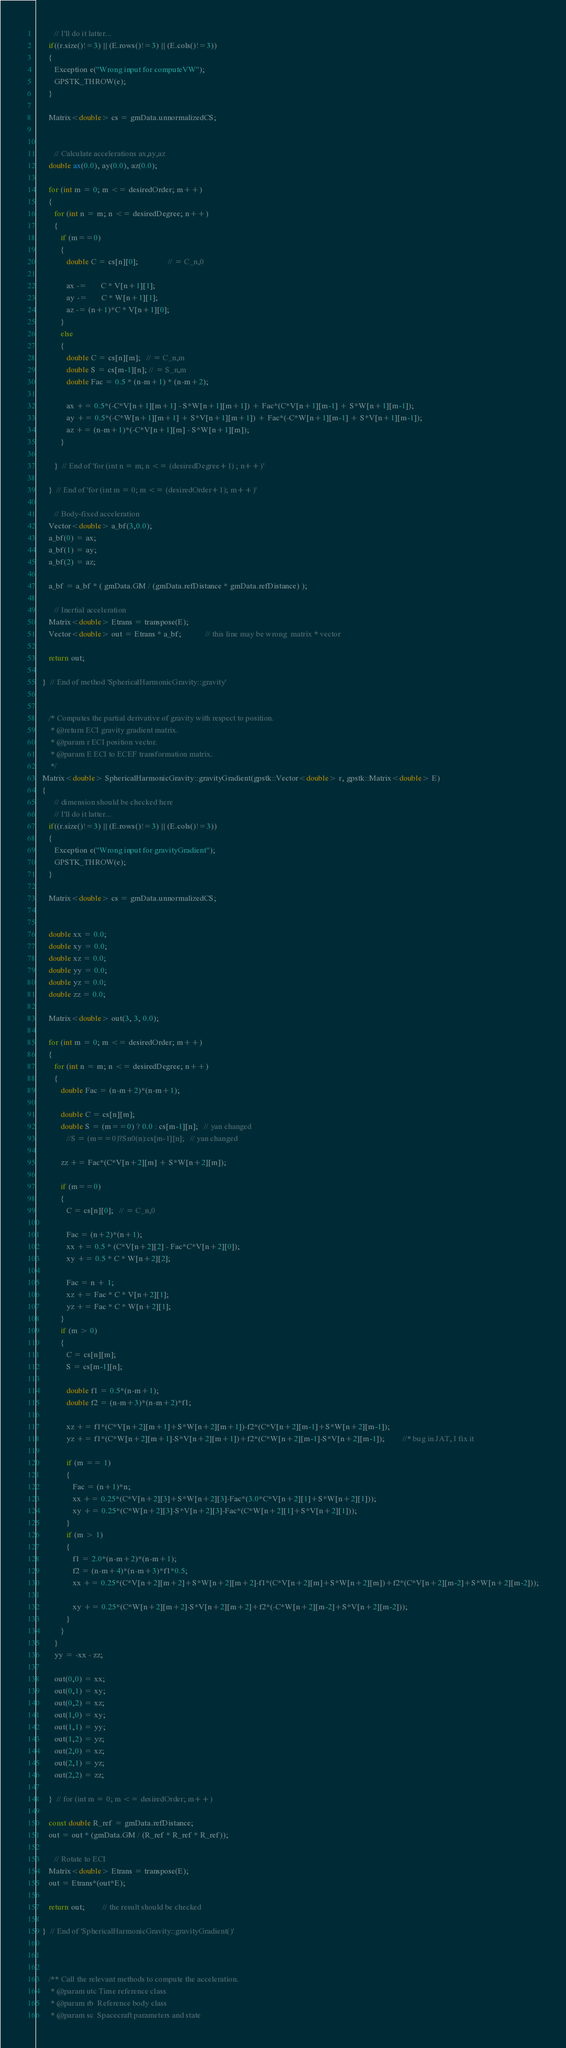<code> <loc_0><loc_0><loc_500><loc_500><_C++_>         // I'll do it latter...
      if((r.size()!=3) || (E.rows()!=3) || (E.cols()!=3))
      {
         Exception e("Wrong input for computeVW");
         GPSTK_THROW(e);
      }

      Matrix<double> cs = gmData.unnormalizedCS;

   
         // Calculate accelerations ax,ay,az
      double ax(0.0), ay(0.0), az(0.0);

      for (int m = 0; m <= desiredOrder; m++)
      {
         for (int n = m; n <= desiredDegree; n++)
         {
            if (m==0) 
            {
               double C = cs[n][0];               // = C_n,0

               ax -=       C * V[n+1][1];
               ay -=       C * W[n+1][1];
               az -= (n+1)*C * V[n+1][0];
            }
            else 
            {
               double C = cs[n][m];   // = C_n,m
               double S = cs[m-1][n]; // = S_n,m
               double Fac = 0.5 * (n-m+1) * (n-m+2);
               
               ax += 0.5*(-C*V[n+1][m+1] - S*W[n+1][m+1]) + Fac*(C*V[n+1][m-1] + S*W[n+1][m-1]);
               ay += 0.5*(-C*W[n+1][m+1] + S*V[n+1][m+1]) + Fac*(-C*W[n+1][m-1] + S*V[n+1][m-1]);
               az += (n-m+1)*(-C*V[n+1][m] - S*W[n+1][m]);
            }

         }  // End of 'for (int n = m; n <= (desiredDegree+1) ; n++)'

      }  // End of 'for (int m = 0; m <= (desiredOrder+1); m++)'

         // Body-fixed acceleration
      Vector<double> a_bf(3,0.0);
      a_bf(0) = ax;
      a_bf(1) = ay;
      a_bf(2) = az;

      a_bf = a_bf * ( gmData.GM / (gmData.refDistance * gmData.refDistance) );

         // Inertial acceleration
      Matrix<double> Etrans = transpose(E);
      Vector<double> out = Etrans * a_bf;            // this line may be wrong  matrix * vector

      return out;

   }  // End of method 'SphericalHarmonicGravity::gravity'


      /* Computes the partial derivative of gravity with respect to position.
       * @return ECI gravity gradient matrix.
       * @param r ECI position vector.
       * @param E ECI to ECEF transformation matrix.
       */
   Matrix<double> SphericalHarmonicGravity::gravityGradient(gpstk::Vector<double> r, gpstk::Matrix<double> E)
   {
         // dimension should be checked here
         // I'll do it latter...
      if((r.size()!=3) || (E.rows()!=3) || (E.cols()!=3))
      {
         Exception e("Wrong input for gravityGradient");
         GPSTK_THROW(e);
      }

      Matrix<double> cs = gmData.unnormalizedCS;

   
      double xx = 0.0;     
      double xy = 0.0;
      double xz = 0.0;
      double yy = 0.0;
      double yz = 0.0;
      double zz = 0.0;

      Matrix<double> out(3, 3, 0.0);

      for (int m = 0; m <= desiredOrder; m++) 
      {
         for (int n = m; n <= desiredDegree; n++) 
         {
            double Fac = (n-m+2)*(n-m+1);
            
            double C = cs[n][m];
            double S = (m==0) ? 0.0 : cs[m-1][n];   // yan changed
               //S = (m==0)?Sn0(n):cs[m-1][n];   // yan changed

            zz += Fac*(C*V[n+2][m] + S*W[n+2][m]);

            if (m==0) 
            {
               C = cs[n][0];   // = C_n,0

               Fac = (n+2)*(n+1);
               xx += 0.5 * (C*V[n+2][2] - Fac*C*V[n+2][0]);
               xy += 0.5 * C * W[n+2][2];
               
               Fac = n + 1;
               xz += Fac * C * V[n+2][1];
               yz += Fac * C * W[n+2][1];
            }
            if (m > 0)
            {
               C = cs[n][m];
               S = cs[m-1][n];
               
               double f1 = 0.5*(n-m+1);
               double f2 = (n-m+3)*(n-m+2)*f1;

               xz += f1*(C*V[n+2][m+1]+S*W[n+2][m+1])-f2*(C*V[n+2][m-1]+S*W[n+2][m-1]);
               yz += f1*(C*W[n+2][m+1]-S*V[n+2][m+1])+f2*(C*W[n+2][m-1]-S*V[n+2][m-1]);         //* bug in JAT, I fix it
          
               if (m == 1)
               {
                  Fac = (n+1)*n;
                  xx += 0.25*(C*V[n+2][3]+S*W[n+2][3]-Fac*(3.0*C*V[n+2][1]+S*W[n+2][1]));
                  xy += 0.25*(C*W[n+2][3]-S*V[n+2][3]-Fac*(C*W[n+2][1]+S*V[n+2][1]));
               }
               if (m > 1) 
               {
                  f1 = 2.0*(n-m+2)*(n-m+1);
                  f2 = (n-m+4)*(n-m+3)*f1*0.5;
                  xx += 0.25*(C*V[n+2][m+2]+S*W[n+2][m+2]-f1*(C*V[n+2][m]+S*W[n+2][m])+f2*(C*V[n+2][m-2]+S*W[n+2][m-2]));

                  xy += 0.25*(C*W[n+2][m+2]-S*V[n+2][m+2]+f2*(-C*W[n+2][m-2]+S*V[n+2][m-2]));
               }
            }
         }
         yy = -xx - zz;
         
         out(0,0) = xx;
         out(0,1) = xy;
         out(0,2) = xz;
         out(1,0) = xy;
         out(1,1) = yy;
         out(1,2) = yz;
         out(2,0) = xz;
         out(2,1) = yz;
         out(2,2) = zz;

      }  // for (int m = 0; m <= desiredOrder; m++) 

      const double R_ref = gmData.refDistance;
      out = out * (gmData.GM / (R_ref * R_ref * R_ref));

         // Rotate to ECI
      Matrix<double> Etrans = transpose(E);
      out = Etrans*(out*E);

      return out;         // the result should be checked

   }  // End of 'SphericalHarmonicGravity::gravityGradient()'

   
      
      /** Call the relevant methods to compute the acceleration.
       * @param utc Time reference class
       * @param rb  Reference body class
       * @param sc  Spacecraft parameters and state</code> 